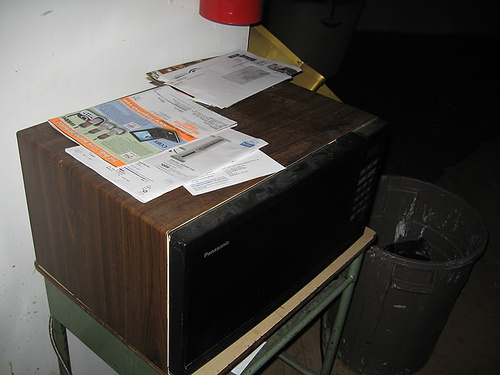Describe the objects in this image and their specific colors. I can see a microwave in darkgray, black, and lightgray tones in this image. 